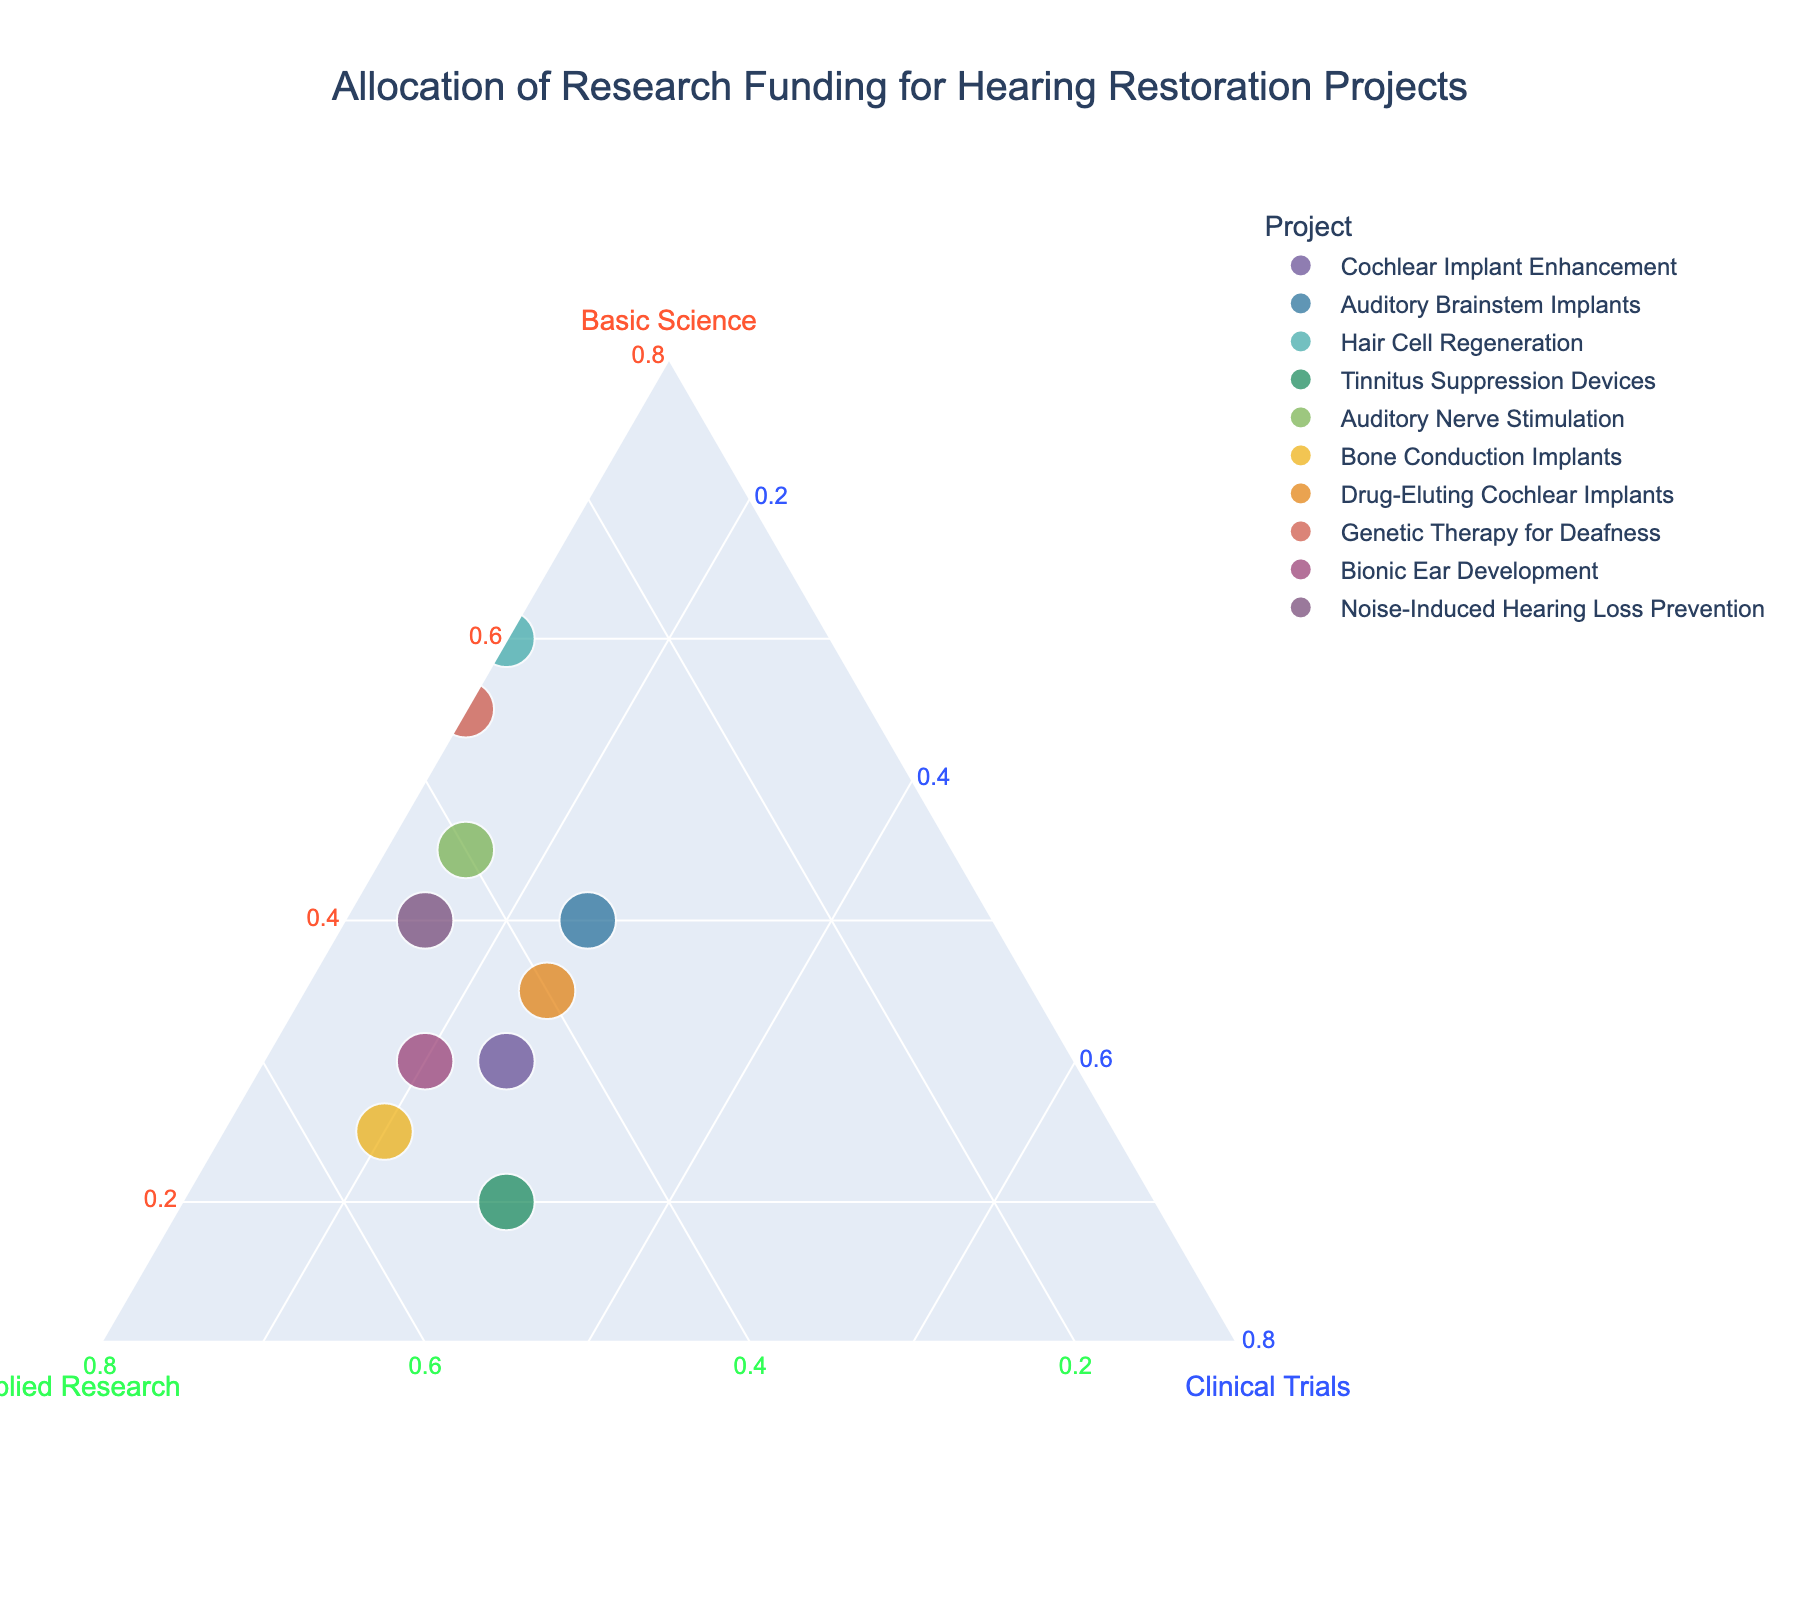1. What is the heading of the figure? The heading typically captures the purpose or focus of the figure, which is displayed prominently above the ternary plot.
Answer: Allocation of Research Funding for Hearing Restoration Projects 2. Which project has the highest percentage of funding allocated to Basic Science? To find this, look for the point closest to the Basic Science corner of the ternary plot, as higher closeness indicates a higher percentage.
Answer: Hair Cell Regeneration 3. How many projects have a funding allocation for Clinical Trials of exactly 25%? Look for the points where the third axis (Clinical Trials) intersects with the 25% line. Verify with labels to ensure accuracy.
Answer: Three projects 4. Which project has equal funding percentages for Basic Science and Clinical Trials? Locate the point on the ternary plot where the distances from the Basic Science and Clinical Trials corners are the same. The legend or hover information can be used to confirm.
Answer: Auditory Brainstem Implants 5. What is the combined percentage of Basic Science and Applied Research funding for Bionic Ear Development? For Bionic Ear Development, add the percentages allocated for Basic Science and Applied Research.
Answer: 80% 6. Between Cochlear Implant Enhancement and Bone Conduction Implants, which project has a higher percentage for Applied Research? Compare the positions of both points relative to the Applied Research corner. Check which project is closer to confirm the higher percentage.
Answer: Bone Conduction Implants 7. How does the funding allocation for Auditory Nerve Stimulation compare across the three categories? Look for the point labeled Auditory Nerve Stimulation and analyze its relative position among the three axes to understand the distribution.
Answer: Basic Science: 45%, Applied Research: 40%, Clinical Trials: 15% 8. Which projects have more than or equal to 50% funding in any one category? Identify points that lie close to any one of the three corners: Basic Science, Applied Research, or Clinical Trials. Confirm the percentages through labels or hover data.
Answer: Hair Cell Regeneration, Tinnitus Suppression Devices, Bone Conduction Implants, Genetic Therapy for Deafness 9. What is the average percentage funding for Clinical Trials across all projects? Calculate the mean by summing the Clinical Trials percentages of all projects and dividing by the number of projects (which is 10).
Answer: 20% 10. Which project has a balanced allocation across all three funding categories? A balanced allocation would be approximately equidistant from all three corners. Confirm by identifying a point close to the center of the ternary plot.
Answer: No project has a perfectly balanced allocation 